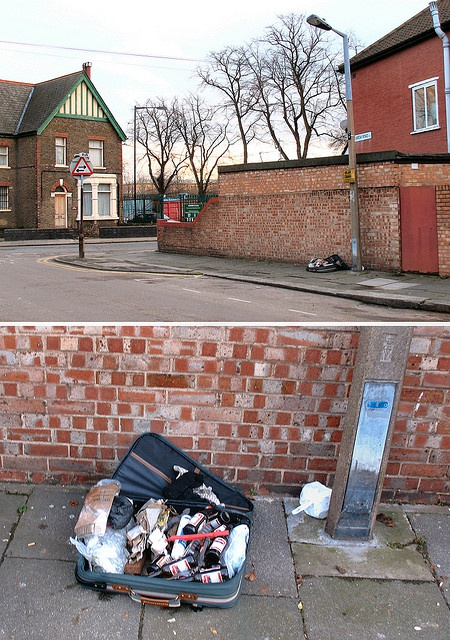Describe the objects in this image and their specific colors. I can see suitcase in white, black, gray, and blue tones, bottle in white, black, and gray tones, bottle in white, black, gray, and darkgray tones, bottle in white, black, and gray tones, and bottle in white, gray, black, and salmon tones in this image. 